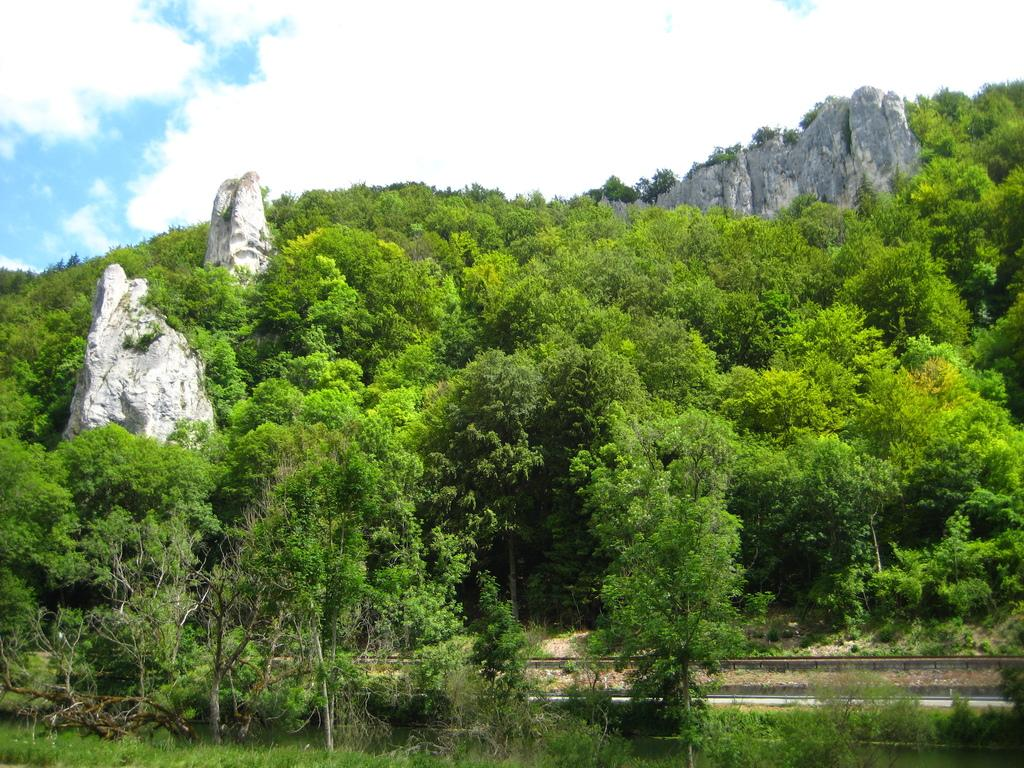What type of natural elements can be seen in the image? There are trees and rocks in the image. What can be seen in the background of the image? There are clouds visible in the background of the image. What historical event is being commemorated by the mask in the image? There is no mask present in the image, so it is not possible to answer that question. 